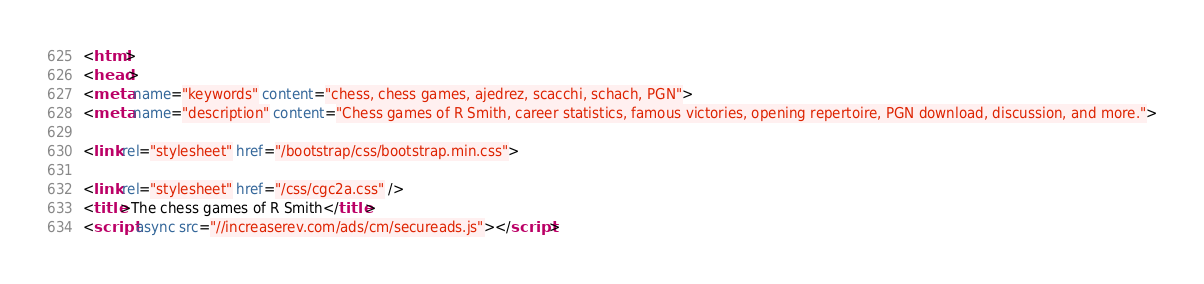<code> <loc_0><loc_0><loc_500><loc_500><_HTML_>
<html>
<head>
<meta name="keywords" content="chess, chess games, ajedrez, scacchi, schach, PGN">
<meta name="description" content="Chess games of R Smith, career statistics, famous victories, opening repertoire, PGN download, discussion, and more.">

<link rel="stylesheet" href="/bootstrap/css/bootstrap.min.css">

<link rel="stylesheet" href="/css/cgc2a.css" />
<title>The chess games of R Smith</title>
<script async src="//increaserev.com/ads/cm/secureads.js"></script>
</code> 